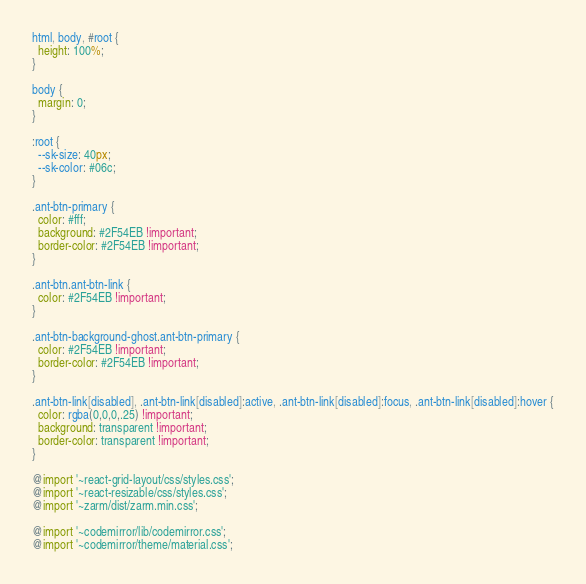<code> <loc_0><loc_0><loc_500><loc_500><_CSS_>html, body, #root {
  height: 100%;
}

body {
  margin: 0;
}

:root {
  --sk-size: 40px;
  --sk-color: #06c;
}

.ant-btn-primary {
  color: #fff;
  background: #2F54EB !important;
  border-color: #2F54EB !important;
}

.ant-btn.ant-btn-link {
  color: #2F54EB !important;
}

.ant-btn-background-ghost.ant-btn-primary {
  color: #2F54EB !important;
  border-color: #2F54EB !important;
}

.ant-btn-link[disabled], .ant-btn-link[disabled]:active, .ant-btn-link[disabled]:focus, .ant-btn-link[disabled]:hover {
  color: rgba(0,0,0,.25) !important;
  background: transparent !important;
  border-color: transparent !important;
}

@import '~react-grid-layout/css/styles.css'; 
@import '~react-resizable/css/styles.css';
@import '~zarm/dist/zarm.min.css';

@import '~codemirror/lib/codemirror.css';
@import '~codemirror/theme/material.css';
</code> 